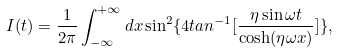Convert formula to latex. <formula><loc_0><loc_0><loc_500><loc_500>I ( t ) = \frac { 1 } { 2 \pi } \int _ { - \infty } ^ { + \infty } d x \sin ^ { 2 } \{ 4 t a n ^ { - 1 } [ \frac { \eta \sin \omega t } { \cosh ( \eta \omega x ) } ] \} ,</formula> 